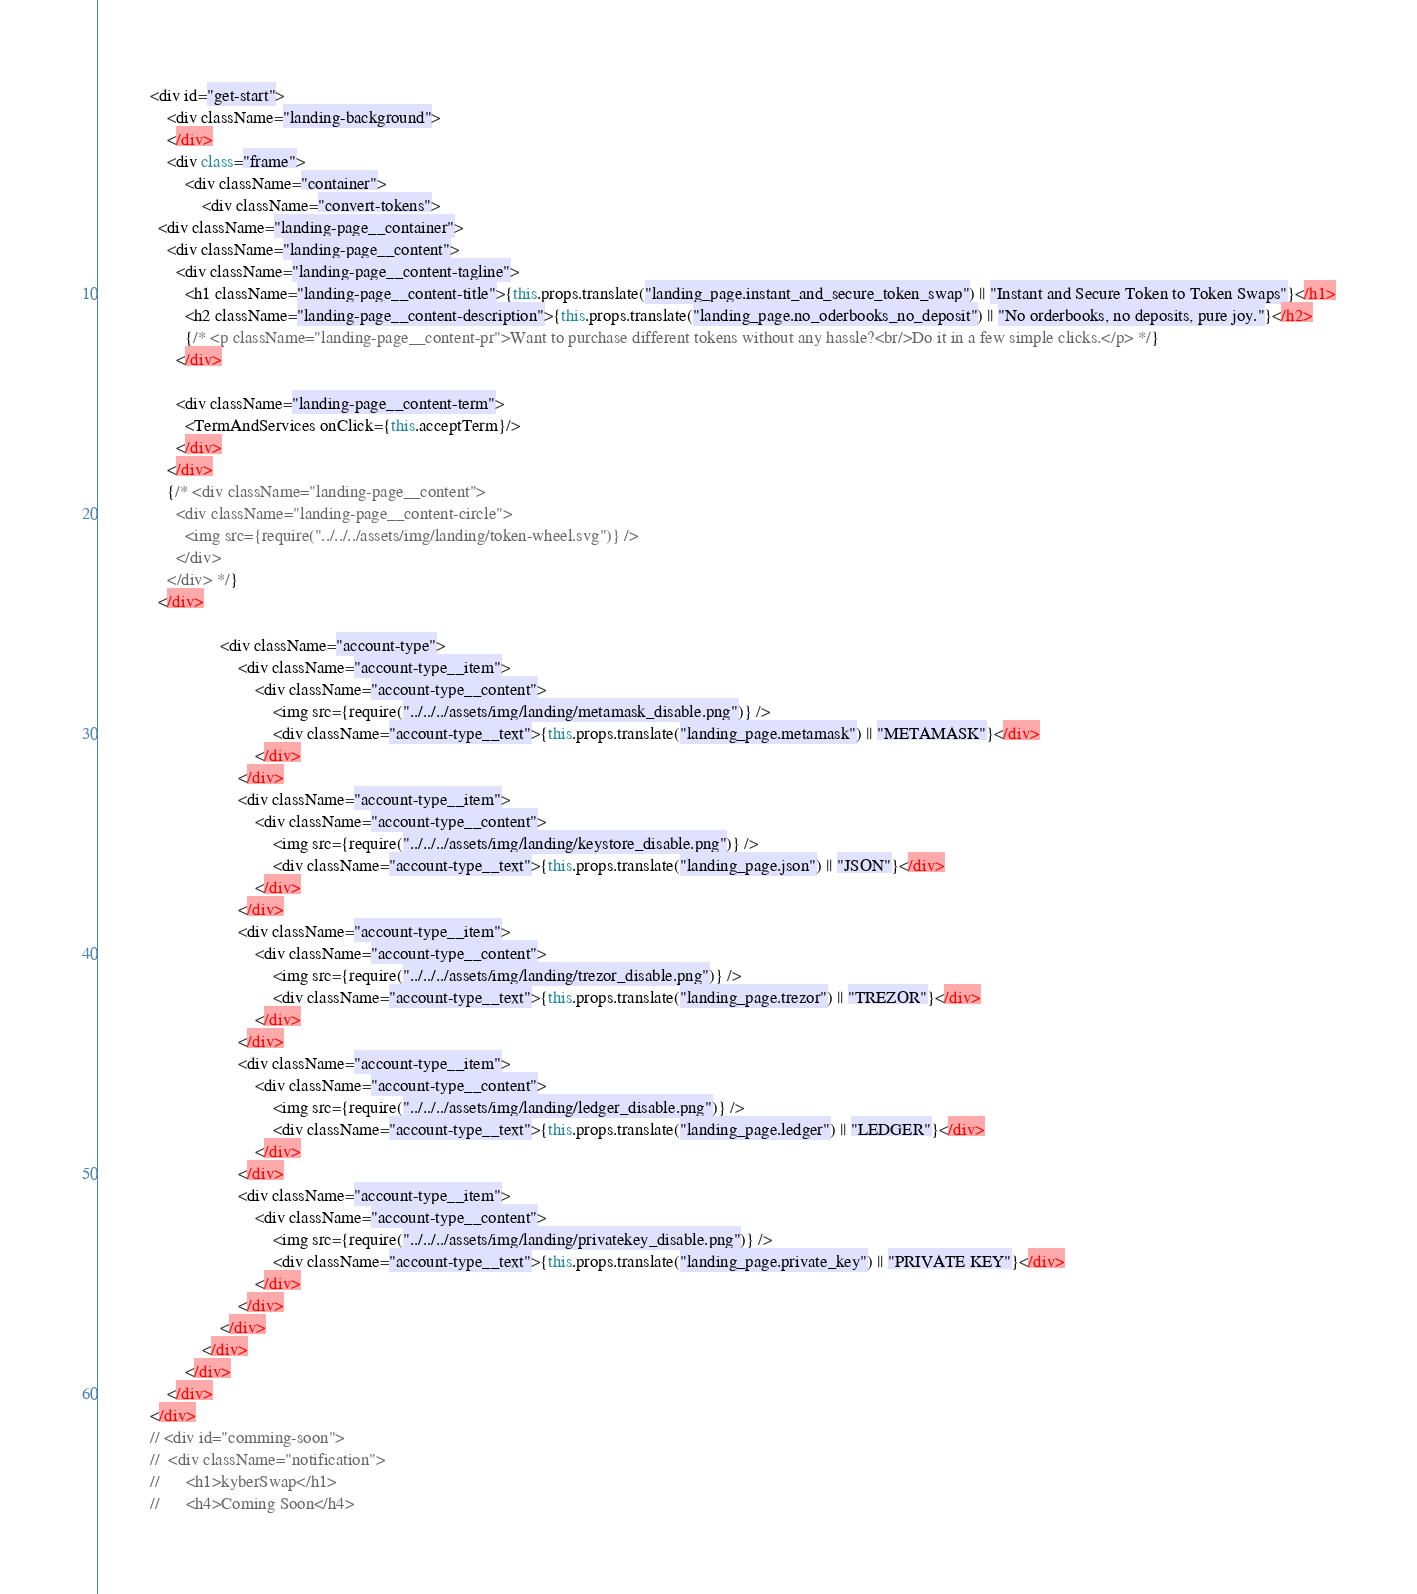Convert code to text. <code><loc_0><loc_0><loc_500><loc_500><_JavaScript_>			<div id="get-start">
				<div className="landing-background">
				</div>
				<div class="frame">
					<div className="container">
						<div className="convert-tokens">
              <div className="landing-page__container">
                <div className="landing-page__content">
                  <div className="landing-page__content-tagline">
                    <h1 className="landing-page__content-title">{this.props.translate("landing_page.instant_and_secure_token_swap") || "Instant and Secure Token to Token Swaps"}</h1>
                    <h2 className="landing-page__content-description">{this.props.translate("landing_page.no_oderbooks_no_deposit") || "No orderbooks, no deposits, pure joy."}</h2>
                    {/* <p className="landing-page__content-pr">Want to purchase different tokens without any hassle?<br/>Do it in a few simple clicks.</p> */}
                  </div>

                  <div className="landing-page__content-term">
                    <TermAndServices onClick={this.acceptTerm}/>                    
                  </div>
                </div>
                {/* <div className="landing-page__content">
                  <div className="landing-page__content-circle">
                    <img src={require("../../../assets/img/landing/token-wheel.svg")} />
                  </div>
                </div> */}
              </div>

							<div className="account-type">
								<div className="account-type__item">
									<div className="account-type__content">
										<img src={require("../../../assets/img/landing/metamask_disable.png")} />
										<div className="account-type__text">{this.props.translate("landing_page.metamask") || "METAMASK"}</div>
									</div>
								</div>
								<div className="account-type__item">
									<div className="account-type__content">
										<img src={require("../../../assets/img/landing/keystore_disable.png")} />
										<div className="account-type__text">{this.props.translate("landing_page.json") || "JSON"}</div>
									</div>
								</div>
								<div className="account-type__item">
									<div className="account-type__content">
										<img src={require("../../../assets/img/landing/trezor_disable.png")} />
										<div className="account-type__text">{this.props.translate("landing_page.trezor") || "TREZOR"}</div>
									</div>
								</div>
								<div className="account-type__item">
									<div className="account-type__content">
										<img src={require("../../../assets/img/landing/ledger_disable.png")} />
										<div className="account-type__text">{this.props.translate("landing_page.ledger") || "LEDGER"}</div>
									</div>
								</div>
								<div className="account-type__item">
									<div className="account-type__content">
										<img src={require("../../../assets/img/landing/privatekey_disable.png")} />
										<div className="account-type__text">{this.props.translate("landing_page.private_key") || "PRIVATE KEY"}</div>
									</div>
								</div>
							</div>
						</div>
					</div>
				</div>
			</div>
			// <div id="comming-soon">
			// 	<div className="notification">
			// 		<h1>kyberSwap</h1>
			// 		<h4>Coming Soon</h4></code> 